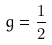Convert formula to latex. <formula><loc_0><loc_0><loc_500><loc_500>g = \frac { 1 } { 2 }</formula> 